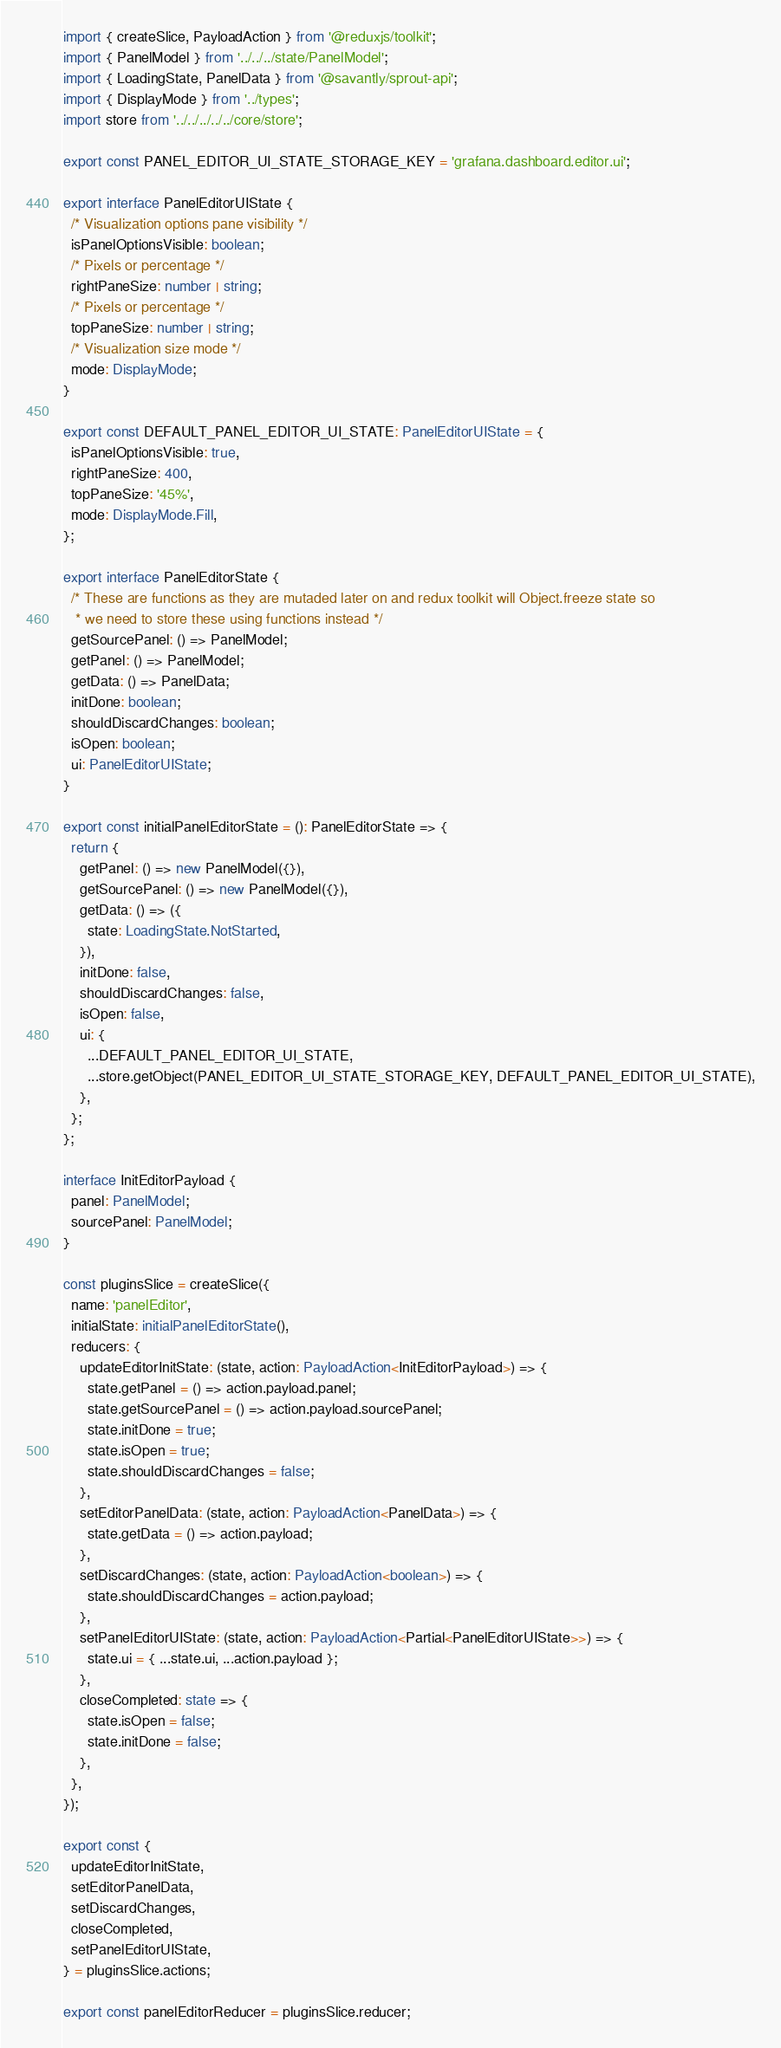Convert code to text. <code><loc_0><loc_0><loc_500><loc_500><_TypeScript_>import { createSlice, PayloadAction } from '@reduxjs/toolkit';
import { PanelModel } from '../../../state/PanelModel';
import { LoadingState, PanelData } from '@savantly/sprout-api';
import { DisplayMode } from '../types';
import store from '../../../../../core/store';

export const PANEL_EDITOR_UI_STATE_STORAGE_KEY = 'grafana.dashboard.editor.ui';

export interface PanelEditorUIState {
  /* Visualization options pane visibility */
  isPanelOptionsVisible: boolean;
  /* Pixels or percentage */
  rightPaneSize: number | string;
  /* Pixels or percentage */
  topPaneSize: number | string;
  /* Visualization size mode */
  mode: DisplayMode;
}

export const DEFAULT_PANEL_EDITOR_UI_STATE: PanelEditorUIState = {
  isPanelOptionsVisible: true,
  rightPaneSize: 400,
  topPaneSize: '45%',
  mode: DisplayMode.Fill,
};

export interface PanelEditorState {
  /* These are functions as they are mutaded later on and redux toolkit will Object.freeze state so
   * we need to store these using functions instead */
  getSourcePanel: () => PanelModel;
  getPanel: () => PanelModel;
  getData: () => PanelData;
  initDone: boolean;
  shouldDiscardChanges: boolean;
  isOpen: boolean;
  ui: PanelEditorUIState;
}

export const initialPanelEditorState = (): PanelEditorState => {
  return {
    getPanel: () => new PanelModel({}),
    getSourcePanel: () => new PanelModel({}),
    getData: () => ({
      state: LoadingState.NotStarted,
    }),
    initDone: false,
    shouldDiscardChanges: false,
    isOpen: false,
    ui: {
      ...DEFAULT_PANEL_EDITOR_UI_STATE,
      ...store.getObject(PANEL_EDITOR_UI_STATE_STORAGE_KEY, DEFAULT_PANEL_EDITOR_UI_STATE),
    },
  };
};

interface InitEditorPayload {
  panel: PanelModel;
  sourcePanel: PanelModel;
}

const pluginsSlice = createSlice({
  name: 'panelEditor',
  initialState: initialPanelEditorState(),
  reducers: {
    updateEditorInitState: (state, action: PayloadAction<InitEditorPayload>) => {
      state.getPanel = () => action.payload.panel;
      state.getSourcePanel = () => action.payload.sourcePanel;
      state.initDone = true;
      state.isOpen = true;
      state.shouldDiscardChanges = false;
    },
    setEditorPanelData: (state, action: PayloadAction<PanelData>) => {
      state.getData = () => action.payload;
    },
    setDiscardChanges: (state, action: PayloadAction<boolean>) => {
      state.shouldDiscardChanges = action.payload;
    },
    setPanelEditorUIState: (state, action: PayloadAction<Partial<PanelEditorUIState>>) => {
      state.ui = { ...state.ui, ...action.payload };
    },
    closeCompleted: state => {
      state.isOpen = false;
      state.initDone = false;
    },
  },
});

export const {
  updateEditorInitState,
  setEditorPanelData,
  setDiscardChanges,
  closeCompleted,
  setPanelEditorUIState,
} = pluginsSlice.actions;

export const panelEditorReducer = pluginsSlice.reducer;
</code> 